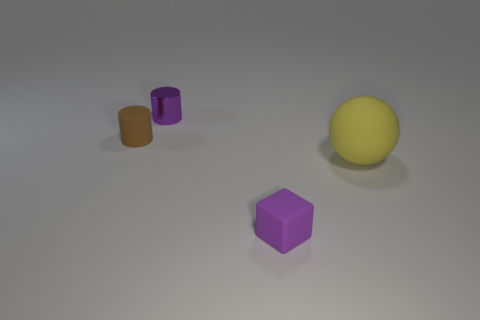Add 4 cubes. How many objects exist? 8 Subtract all cubes. How many objects are left? 3 Subtract 0 green cubes. How many objects are left? 4 Subtract 2 cylinders. How many cylinders are left? 0 Subtract all cyan spheres. Subtract all purple cylinders. How many spheres are left? 1 Subtract all purple blocks. How many blue balls are left? 0 Subtract all large yellow spheres. Subtract all small blue objects. How many objects are left? 3 Add 4 purple things. How many purple things are left? 6 Add 4 purple cubes. How many purple cubes exist? 5 